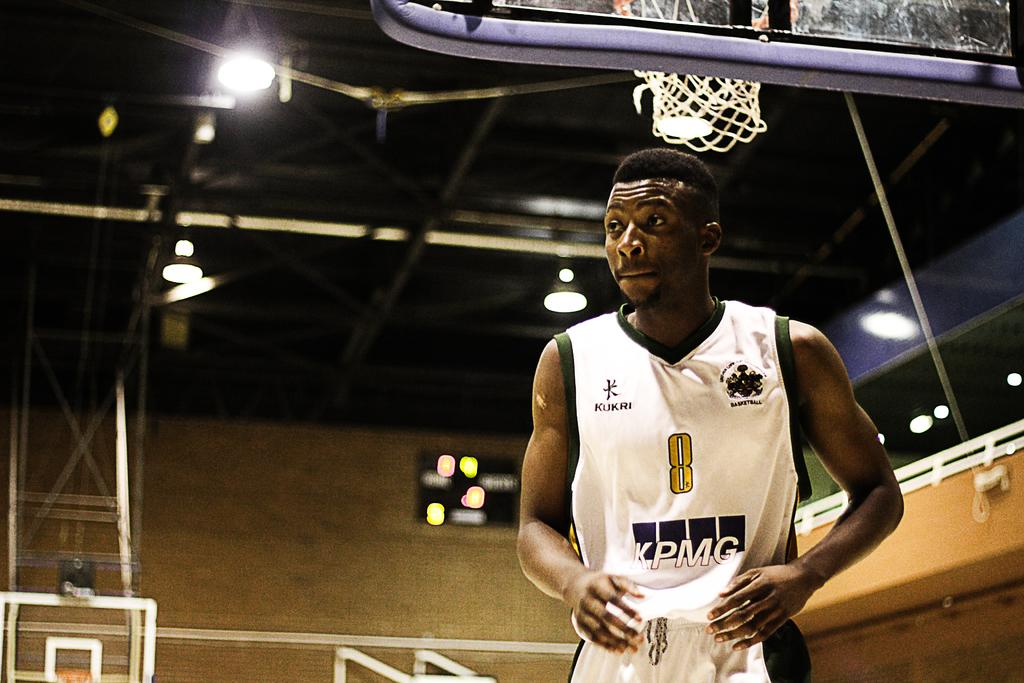Provide a one-sentence caption for the provided image. A basketball player standing in an arena wearing number 8. 